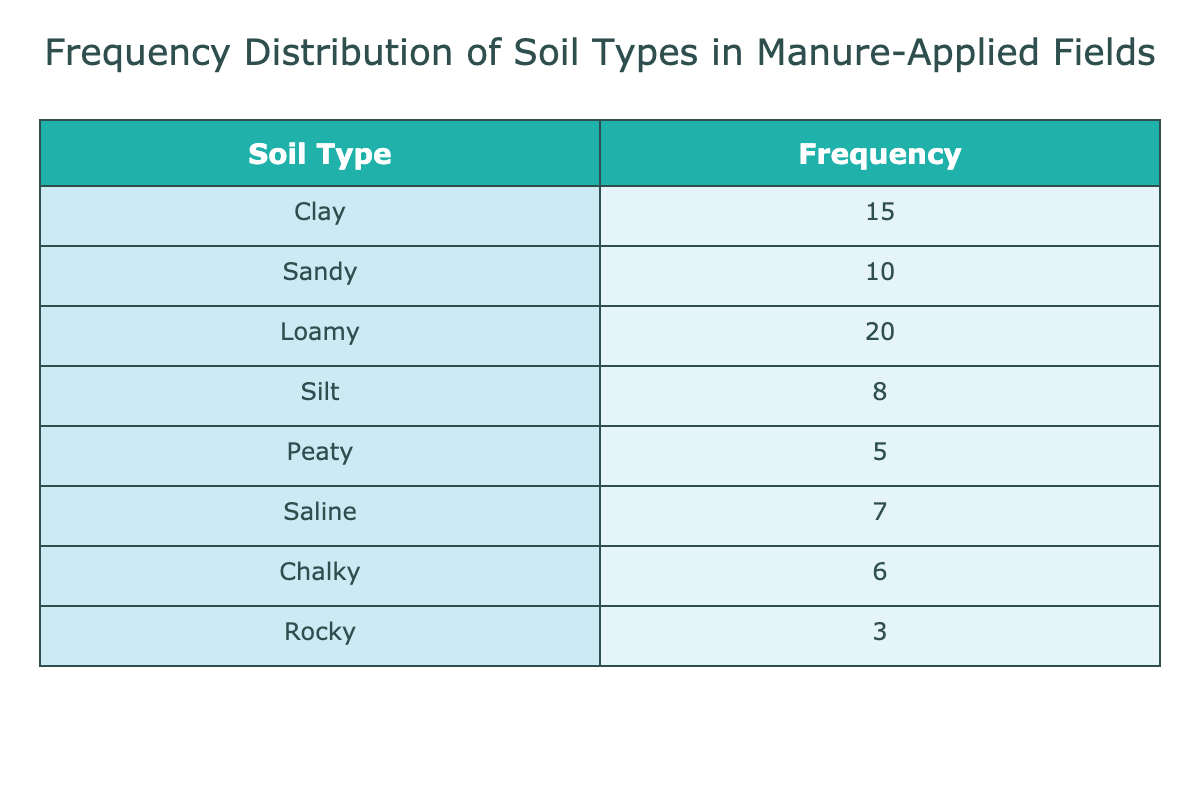What is the most frequent soil type where manure is applied? The table shows a list of soil types along with their frequencies. The highest frequency value is for Loamy, which occurs 20 times.
Answer: Loamy How many soil types have a frequency of less than 10? The table lists the frequencies as Peaty (5), Silt (8), and Rocky (3). There are three soil types with a frequency of less than 10.
Answer: 3 What is the total frequency of Clay and Sandy soil types combined? The frequency of Clay is 15 and Sandy is 10. Adding these two values gives 15 + 10 = 25.
Answer: 25 Is the frequency of Saline soil type greater than that of Chalky? The table shows Saline has a frequency of 7 and Chalky has a frequency of 6. Since 7 is greater than 6, the statement is true.
Answer: Yes What percentage of the fields have Peaty soil type compared to the total frequency? The total frequency can be calculated by summing all frequency values: 15 + 10 + 20 + 8 + 5 + 7 + 6 + 3 = 74. The percentage of Peaty is (5/74) * 100 = approximately 6.76%.
Answer: 6.76% How many more occurrences of Loamy soil types are there than Rocky soil types? The frequency for Loamy is 20 and for Rocky is 3. Subtracting these values gives 20 - 3 = 17.
Answer: 17 What is the average frequency of all soil types listed in the table? To find the average, sum all frequencies (15 + 10 + 20 + 8 + 5 + 7 + 6 + 3 = 74) and divide by the number of soil types (8). So the average is 74 / 8 = 9.25.
Answer: 9.25 Is there a soil type with a frequency of exactly 6? Checking the frequencies, Chalky has a frequency of 6, making this statement true.
Answer: Yes 